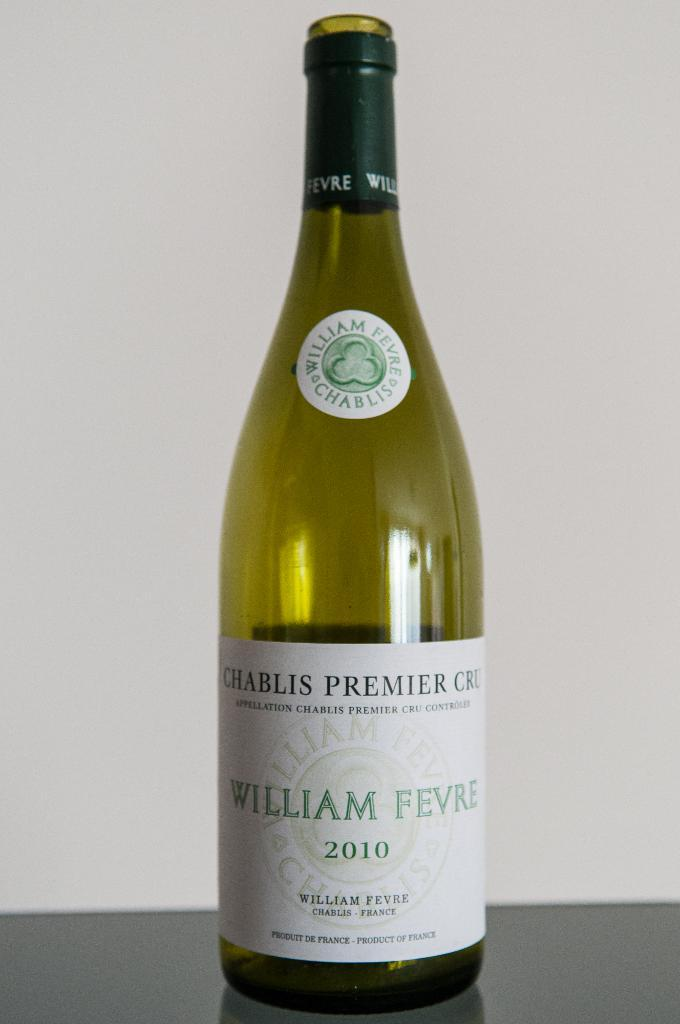Provide a one-sentence caption for the provided image. An emtpy 2010 bottle of William Fevre chablis premier cru. 